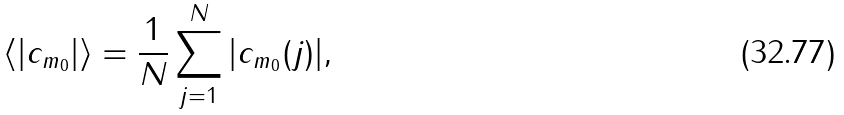Convert formula to latex. <formula><loc_0><loc_0><loc_500><loc_500>\langle | c _ { m _ { 0 } } | \rangle = \frac { 1 } { N } \sum _ { j = 1 } ^ { N } | c _ { m _ { 0 } } ( j ) | ,</formula> 